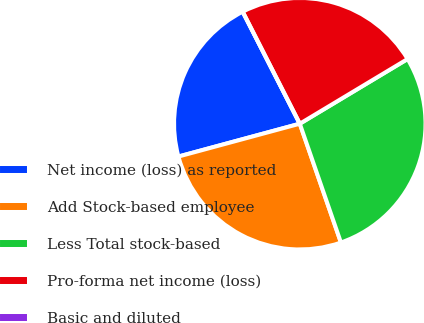Convert chart. <chart><loc_0><loc_0><loc_500><loc_500><pie_chart><fcel>Net income (loss) as reported<fcel>Add Stock-based employee<fcel>Less Total stock-based<fcel>Pro-forma net income (loss)<fcel>Basic and diluted<nl><fcel>21.7%<fcel>26.1%<fcel>28.3%<fcel>23.9%<fcel>0.0%<nl></chart> 